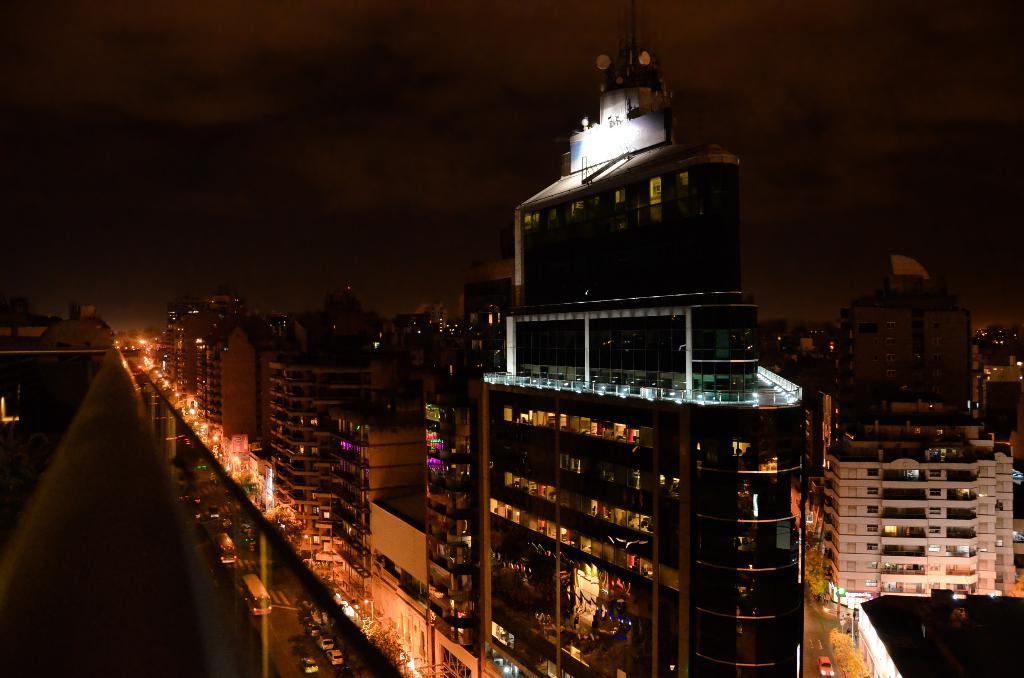What type of structures can be seen in the image? There are buildings in the image. What can be seen illuminating the scene in the image? There are lights in the image. What type of natural elements are present in the image? There are trees in the image. What type of transportation is visible on the road in the image? There are vehicles on the road in the image. What is visible in the background of the image? There is sky visible in the background of the image. What type of discussion is taking place at the feast in the image? There is no feast or discussion present in the image. What type of street is visible in the image? There is no street visible in the image; only buildings, lights, trees, vehicles, and sky are present. 